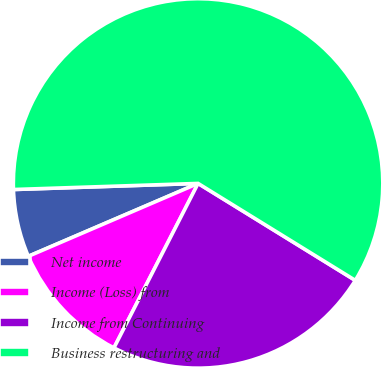<chart> <loc_0><loc_0><loc_500><loc_500><pie_chart><fcel>Net income<fcel>Income (Loss) from<fcel>Income from Continuing<fcel>Business restructuring and<nl><fcel>5.93%<fcel>11.02%<fcel>23.73%<fcel>59.32%<nl></chart> 